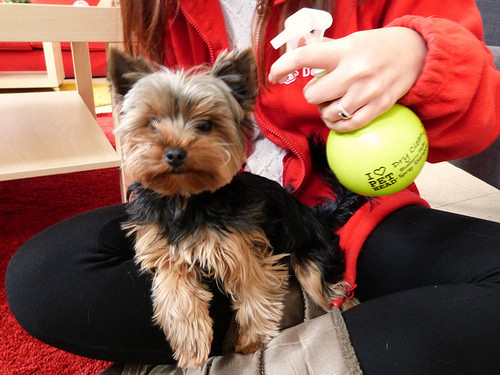<image>
Is the dog on the person? Yes. Looking at the image, I can see the dog is positioned on top of the person, with the person providing support. Is there a dog in front of the spray bottle? No. The dog is not in front of the spray bottle. The spatial positioning shows a different relationship between these objects. 